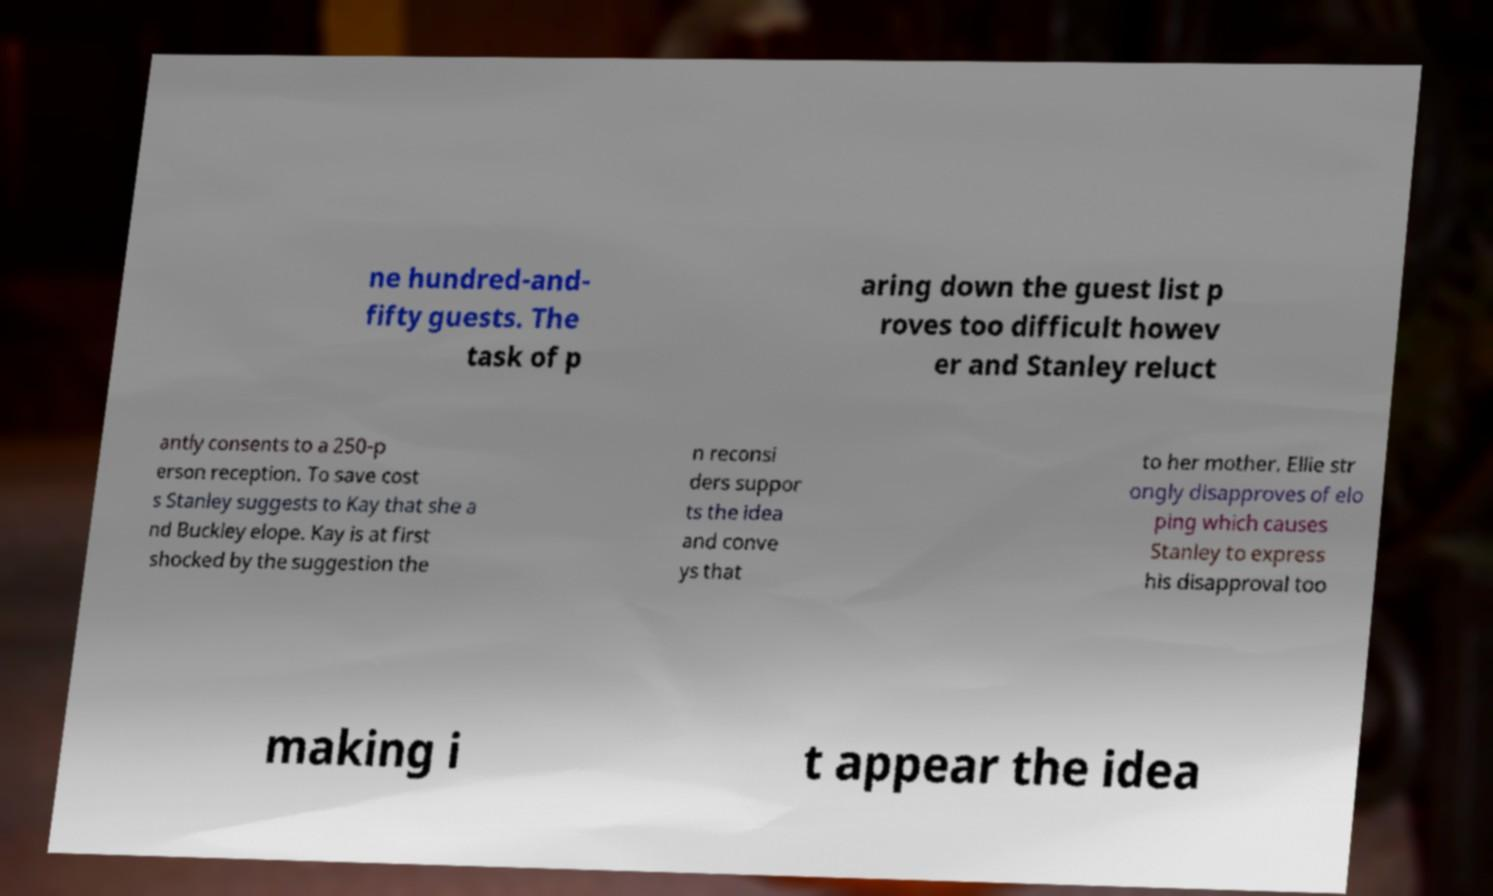There's text embedded in this image that I need extracted. Can you transcribe it verbatim? ne hundred-and- fifty guests. The task of p aring down the guest list p roves too difficult howev er and Stanley reluct antly consents to a 250-p erson reception. To save cost s Stanley suggests to Kay that she a nd Buckley elope. Kay is at first shocked by the suggestion the n reconsi ders suppor ts the idea and conve ys that to her mother. Ellie str ongly disapproves of elo ping which causes Stanley to express his disapproval too making i t appear the idea 